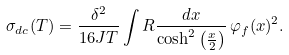Convert formula to latex. <formula><loc_0><loc_0><loc_500><loc_500>\sigma _ { d c } ( T ) = \frac { \delta ^ { 2 } } { 1 6 J T } \int R \frac { d x } { \cosh ^ { 2 } \left ( \frac { x } { 2 } \right ) } \, \varphi _ { f } ( x ) ^ { 2 } .</formula> 